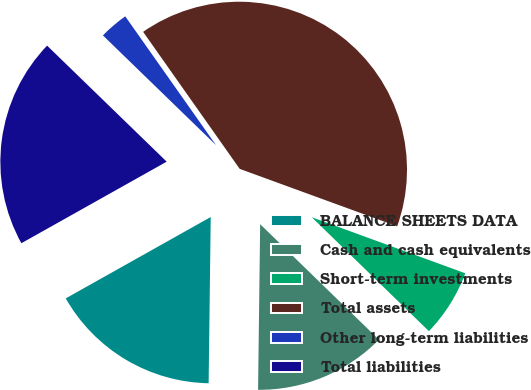Convert chart. <chart><loc_0><loc_0><loc_500><loc_500><pie_chart><fcel>BALANCE SHEETS DATA<fcel>Cash and cash equivalents<fcel>Short-term investments<fcel>Total assets<fcel>Other long-term liabilities<fcel>Total liabilities<nl><fcel>16.66%<fcel>12.92%<fcel>6.71%<fcel>40.34%<fcel>2.97%<fcel>20.4%<nl></chart> 